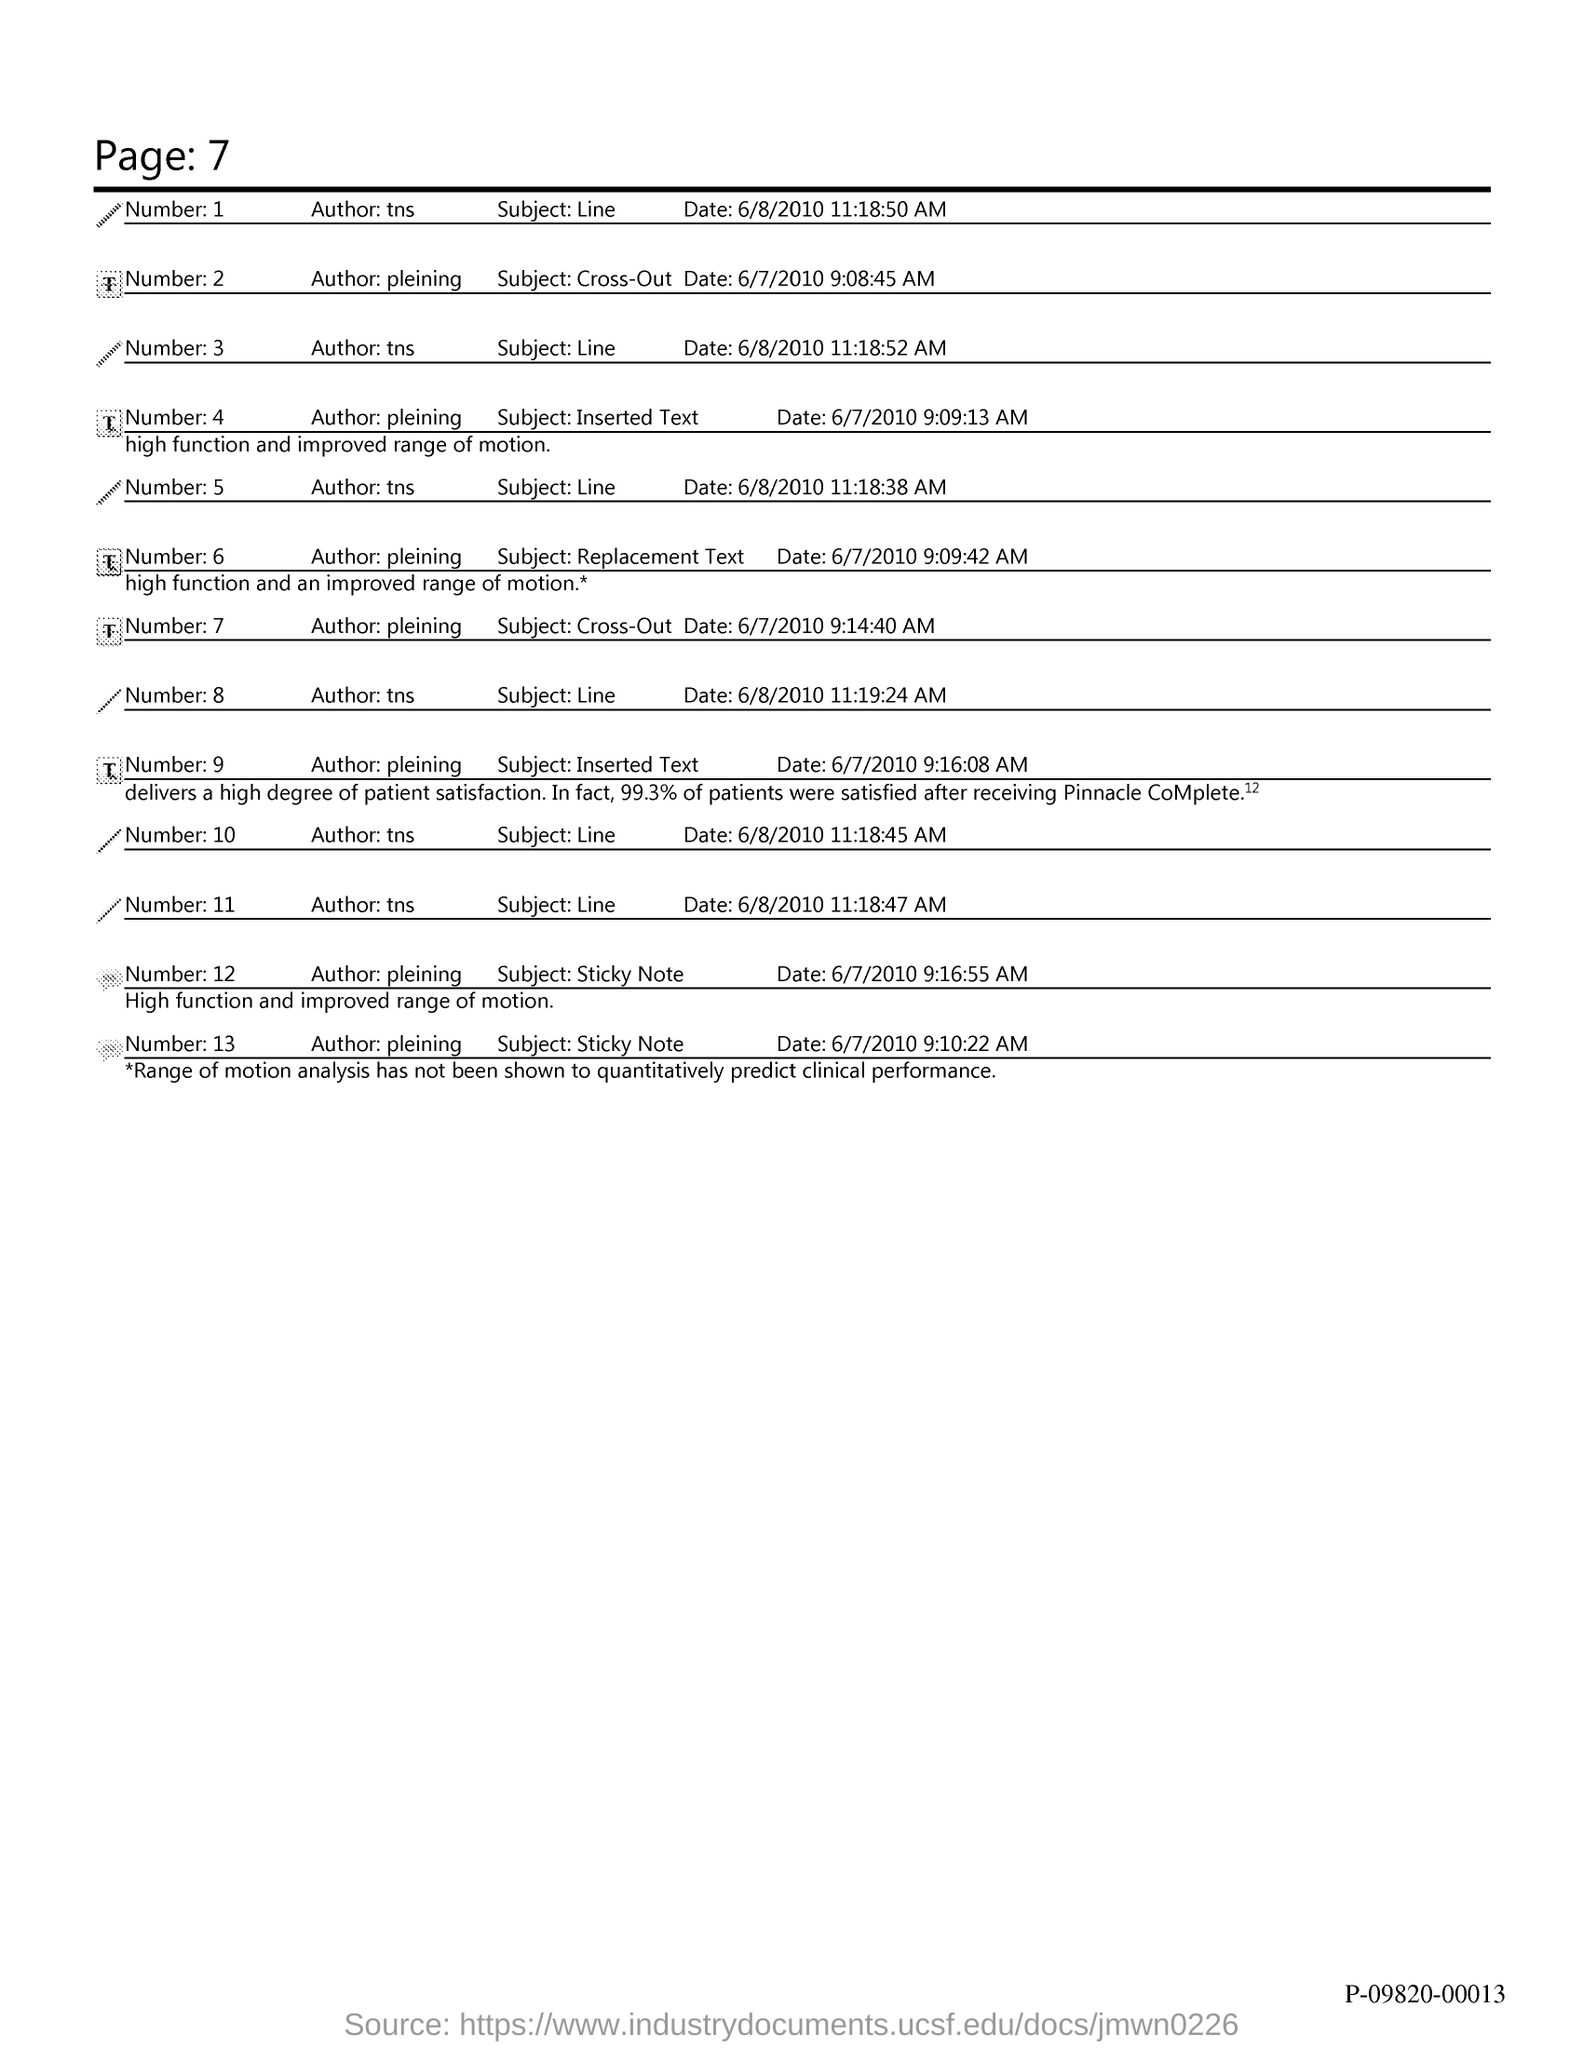Identify some key points in this picture. The page number at the top of the page is 7. 